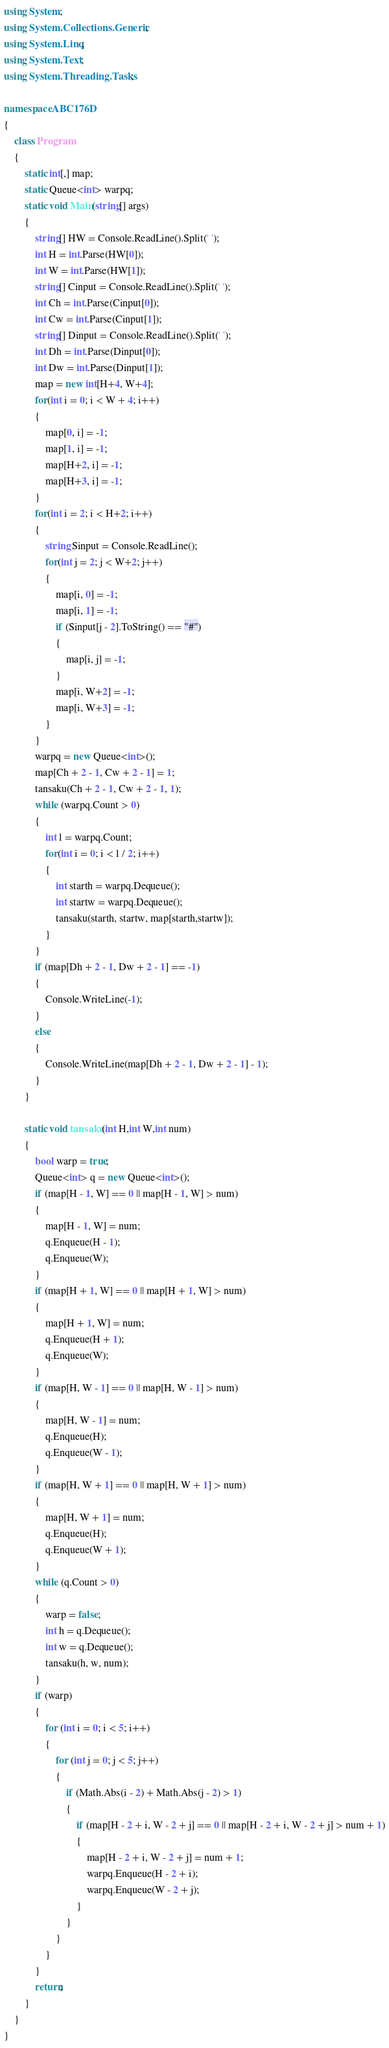<code> <loc_0><loc_0><loc_500><loc_500><_C#_>using System;
using System.Collections.Generic;
using System.Linq;
using System.Text;
using System.Threading.Tasks;

namespace ABC176D
{
    class Program
    {
        static int[,] map;
        static Queue<int> warpq;
        static void Main(string[] args)
        {
            string[] HW = Console.ReadLine().Split(' ');
            int H = int.Parse(HW[0]);
            int W = int.Parse(HW[1]);
            string[] Cinput = Console.ReadLine().Split(' ');
            int Ch = int.Parse(Cinput[0]);
            int Cw = int.Parse(Cinput[1]);
            string[] Dinput = Console.ReadLine().Split(' ');
            int Dh = int.Parse(Dinput[0]);
            int Dw = int.Parse(Dinput[1]);
            map = new int[H+4, W+4];
            for(int i = 0; i < W + 4; i++)
            {
                map[0, i] = -1;
                map[1, i] = -1;
                map[H+2, i] = -1;
                map[H+3, i] = -1;
            }
            for(int i = 2; i < H+2; i++)
            {
                string Sinput = Console.ReadLine();
                for(int j = 2; j < W+2; j++)
                {
                    map[i, 0] = -1;
                    map[i, 1] = -1;
                    if (Sinput[j - 2].ToString() == "#")
                    {
                        map[i, j] = -1;
                    }
                    map[i, W+2] = -1;
                    map[i, W+3] = -1;
                }
            }
            warpq = new Queue<int>();
            map[Ch + 2 - 1, Cw + 2 - 1] = 1;
            tansaku(Ch + 2 - 1, Cw + 2 - 1, 1);
            while (warpq.Count > 0)
            {
                int l = warpq.Count;
                for(int i = 0; i < l / 2; i++)
                {
                    int starth = warpq.Dequeue();
                    int startw = warpq.Dequeue();
                    tansaku(starth, startw, map[starth,startw]);
                }
            }
            if (map[Dh + 2 - 1, Dw + 2 - 1] == -1)
            {
                Console.WriteLine(-1);
            }
            else
            {
                Console.WriteLine(map[Dh + 2 - 1, Dw + 2 - 1] - 1);
            }
        }

        static void tansaku(int H,int W,int num)
        {
            bool warp = true;
            Queue<int> q = new Queue<int>();
            if (map[H - 1, W] == 0 || map[H - 1, W] > num)
            {
                map[H - 1, W] = num;
                q.Enqueue(H - 1);
                q.Enqueue(W);
            }
            if (map[H + 1, W] == 0 || map[H + 1, W] > num)
            {
                map[H + 1, W] = num;
                q.Enqueue(H + 1);
                q.Enqueue(W);
            }
            if (map[H, W - 1] == 0 || map[H, W - 1] > num)
            {
                map[H, W - 1] = num;
                q.Enqueue(H);
                q.Enqueue(W - 1);
            }
            if (map[H, W + 1] == 0 || map[H, W + 1] > num)
            {
                map[H, W + 1] = num;
                q.Enqueue(H);
                q.Enqueue(W + 1);
            }
            while (q.Count > 0)
            {
                warp = false;
                int h = q.Dequeue();
                int w = q.Dequeue();
                tansaku(h, w, num);
            }
            if (warp)
            {
                for (int i = 0; i < 5; i++)
                {
                    for (int j = 0; j < 5; j++)
                    {
                        if (Math.Abs(i - 2) + Math.Abs(j - 2) > 1)
                        {
                            if (map[H - 2 + i, W - 2 + j] == 0 || map[H - 2 + i, W - 2 + j] > num + 1)
                            {
                                map[H - 2 + i, W - 2 + j] = num + 1;
                                warpq.Enqueue(H - 2 + i);
                                warpq.Enqueue(W - 2 + j);
                            }
                        }
                    }
                }
            }
            return;
        }
    }
}
</code> 